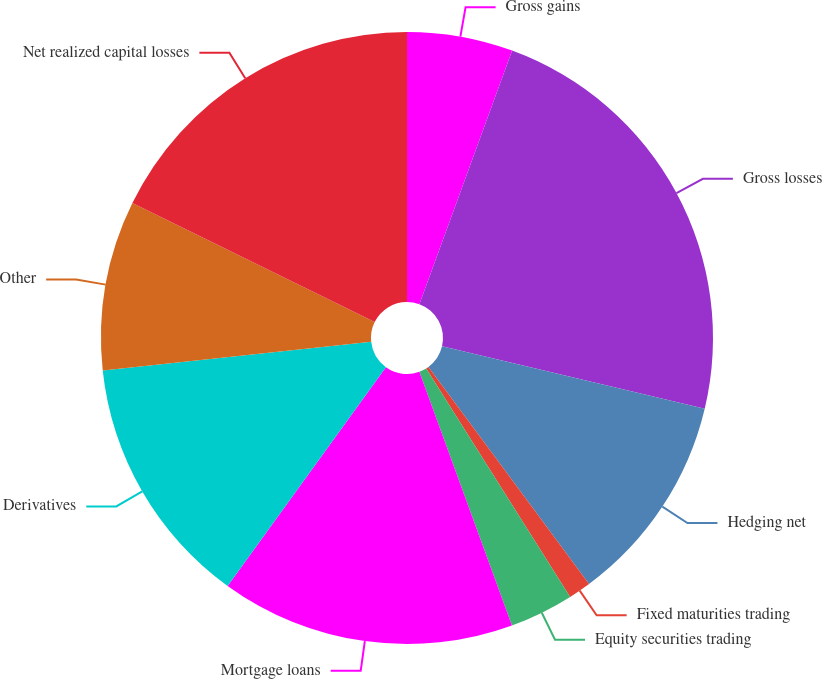<chart> <loc_0><loc_0><loc_500><loc_500><pie_chart><fcel>Gross gains<fcel>Gross losses<fcel>Hedging net<fcel>Fixed maturities trading<fcel>Equity securities trading<fcel>Mortgage loans<fcel>Derivatives<fcel>Other<fcel>Net realized capital losses<nl><fcel>5.58%<fcel>23.13%<fcel>11.15%<fcel>1.19%<fcel>3.38%<fcel>15.54%<fcel>13.34%<fcel>8.96%<fcel>17.73%<nl></chart> 